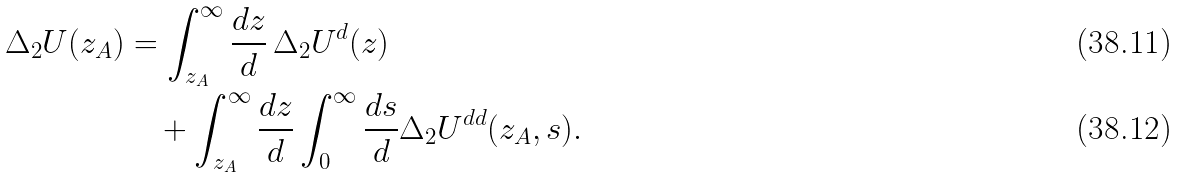<formula> <loc_0><loc_0><loc_500><loc_500>\Delta _ { 2 } U ( z _ { A } ) & = \int _ { z _ { A } } ^ { \infty } \frac { d z } { d } \, \Delta _ { 2 } U ^ { d } ( z ) \\ & \quad + \int _ { z _ { A } } ^ { \infty } \frac { d z } { d } \int _ { 0 } ^ { \infty } \frac { d s } { d } \Delta _ { 2 } U ^ { d d } ( z _ { A } , s ) .</formula> 